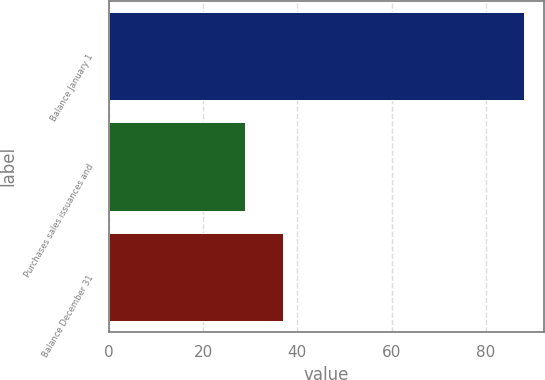Convert chart to OTSL. <chart><loc_0><loc_0><loc_500><loc_500><bar_chart><fcel>Balance January 1<fcel>Purchases sales issuances and<fcel>Balance December 31<nl><fcel>88<fcel>29<fcel>37<nl></chart> 